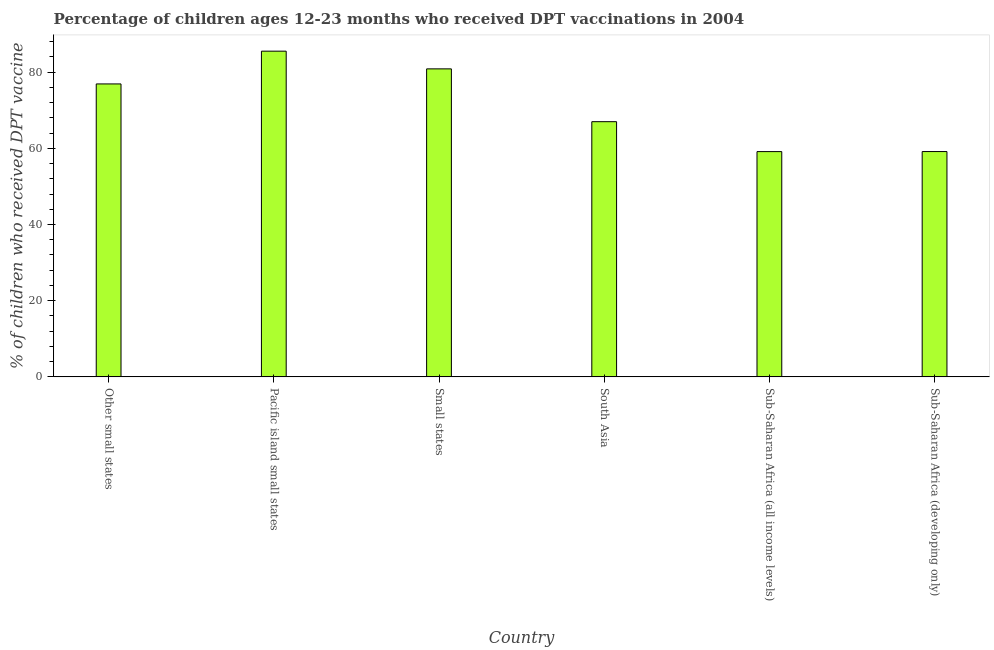What is the title of the graph?
Your answer should be very brief. Percentage of children ages 12-23 months who received DPT vaccinations in 2004. What is the label or title of the Y-axis?
Keep it short and to the point. % of children who received DPT vaccine. What is the percentage of children who received dpt vaccine in Sub-Saharan Africa (developing only)?
Offer a very short reply. 59.14. Across all countries, what is the maximum percentage of children who received dpt vaccine?
Provide a succinct answer. 85.5. Across all countries, what is the minimum percentage of children who received dpt vaccine?
Provide a short and direct response. 59.13. In which country was the percentage of children who received dpt vaccine maximum?
Offer a very short reply. Pacific island small states. In which country was the percentage of children who received dpt vaccine minimum?
Give a very brief answer. Sub-Saharan Africa (all income levels). What is the sum of the percentage of children who received dpt vaccine?
Your answer should be very brief. 428.5. What is the difference between the percentage of children who received dpt vaccine in Other small states and South Asia?
Provide a short and direct response. 9.91. What is the average percentage of children who received dpt vaccine per country?
Make the answer very short. 71.42. What is the median percentage of children who received dpt vaccine?
Make the answer very short. 71.94. What is the difference between the highest and the second highest percentage of children who received dpt vaccine?
Make the answer very short. 4.65. Is the sum of the percentage of children who received dpt vaccine in Pacific island small states and Sub-Saharan Africa (developing only) greater than the maximum percentage of children who received dpt vaccine across all countries?
Your answer should be compact. Yes. What is the difference between the highest and the lowest percentage of children who received dpt vaccine?
Make the answer very short. 26.36. How many bars are there?
Your response must be concise. 6. Are all the bars in the graph horizontal?
Your response must be concise. No. What is the difference between two consecutive major ticks on the Y-axis?
Make the answer very short. 20. Are the values on the major ticks of Y-axis written in scientific E-notation?
Keep it short and to the point. No. What is the % of children who received DPT vaccine of Other small states?
Offer a terse response. 76.89. What is the % of children who received DPT vaccine of Pacific island small states?
Provide a succinct answer. 85.5. What is the % of children who received DPT vaccine in Small states?
Keep it short and to the point. 80.85. What is the % of children who received DPT vaccine of South Asia?
Your answer should be compact. 66.99. What is the % of children who received DPT vaccine of Sub-Saharan Africa (all income levels)?
Your response must be concise. 59.13. What is the % of children who received DPT vaccine of Sub-Saharan Africa (developing only)?
Your answer should be very brief. 59.14. What is the difference between the % of children who received DPT vaccine in Other small states and Pacific island small states?
Keep it short and to the point. -8.6. What is the difference between the % of children who received DPT vaccine in Other small states and Small states?
Keep it short and to the point. -3.95. What is the difference between the % of children who received DPT vaccine in Other small states and South Asia?
Offer a terse response. 9.91. What is the difference between the % of children who received DPT vaccine in Other small states and Sub-Saharan Africa (all income levels)?
Make the answer very short. 17.76. What is the difference between the % of children who received DPT vaccine in Other small states and Sub-Saharan Africa (developing only)?
Offer a very short reply. 17.75. What is the difference between the % of children who received DPT vaccine in Pacific island small states and Small states?
Keep it short and to the point. 4.65. What is the difference between the % of children who received DPT vaccine in Pacific island small states and South Asia?
Your answer should be compact. 18.51. What is the difference between the % of children who received DPT vaccine in Pacific island small states and Sub-Saharan Africa (all income levels)?
Offer a terse response. 26.36. What is the difference between the % of children who received DPT vaccine in Pacific island small states and Sub-Saharan Africa (developing only)?
Offer a terse response. 26.35. What is the difference between the % of children who received DPT vaccine in Small states and South Asia?
Offer a terse response. 13.86. What is the difference between the % of children who received DPT vaccine in Small states and Sub-Saharan Africa (all income levels)?
Provide a short and direct response. 21.72. What is the difference between the % of children who received DPT vaccine in Small states and Sub-Saharan Africa (developing only)?
Offer a very short reply. 21.7. What is the difference between the % of children who received DPT vaccine in South Asia and Sub-Saharan Africa (all income levels)?
Offer a terse response. 7.85. What is the difference between the % of children who received DPT vaccine in South Asia and Sub-Saharan Africa (developing only)?
Offer a terse response. 7.84. What is the difference between the % of children who received DPT vaccine in Sub-Saharan Africa (all income levels) and Sub-Saharan Africa (developing only)?
Your answer should be very brief. -0.01. What is the ratio of the % of children who received DPT vaccine in Other small states to that in Pacific island small states?
Provide a succinct answer. 0.9. What is the ratio of the % of children who received DPT vaccine in Other small states to that in Small states?
Make the answer very short. 0.95. What is the ratio of the % of children who received DPT vaccine in Other small states to that in South Asia?
Your answer should be compact. 1.15. What is the ratio of the % of children who received DPT vaccine in Other small states to that in Sub-Saharan Africa (all income levels)?
Make the answer very short. 1.3. What is the ratio of the % of children who received DPT vaccine in Pacific island small states to that in Small states?
Give a very brief answer. 1.06. What is the ratio of the % of children who received DPT vaccine in Pacific island small states to that in South Asia?
Keep it short and to the point. 1.28. What is the ratio of the % of children who received DPT vaccine in Pacific island small states to that in Sub-Saharan Africa (all income levels)?
Offer a terse response. 1.45. What is the ratio of the % of children who received DPT vaccine in Pacific island small states to that in Sub-Saharan Africa (developing only)?
Give a very brief answer. 1.45. What is the ratio of the % of children who received DPT vaccine in Small states to that in South Asia?
Keep it short and to the point. 1.21. What is the ratio of the % of children who received DPT vaccine in Small states to that in Sub-Saharan Africa (all income levels)?
Keep it short and to the point. 1.37. What is the ratio of the % of children who received DPT vaccine in Small states to that in Sub-Saharan Africa (developing only)?
Offer a very short reply. 1.37. What is the ratio of the % of children who received DPT vaccine in South Asia to that in Sub-Saharan Africa (all income levels)?
Your answer should be compact. 1.13. What is the ratio of the % of children who received DPT vaccine in South Asia to that in Sub-Saharan Africa (developing only)?
Provide a succinct answer. 1.13. What is the ratio of the % of children who received DPT vaccine in Sub-Saharan Africa (all income levels) to that in Sub-Saharan Africa (developing only)?
Your response must be concise. 1. 